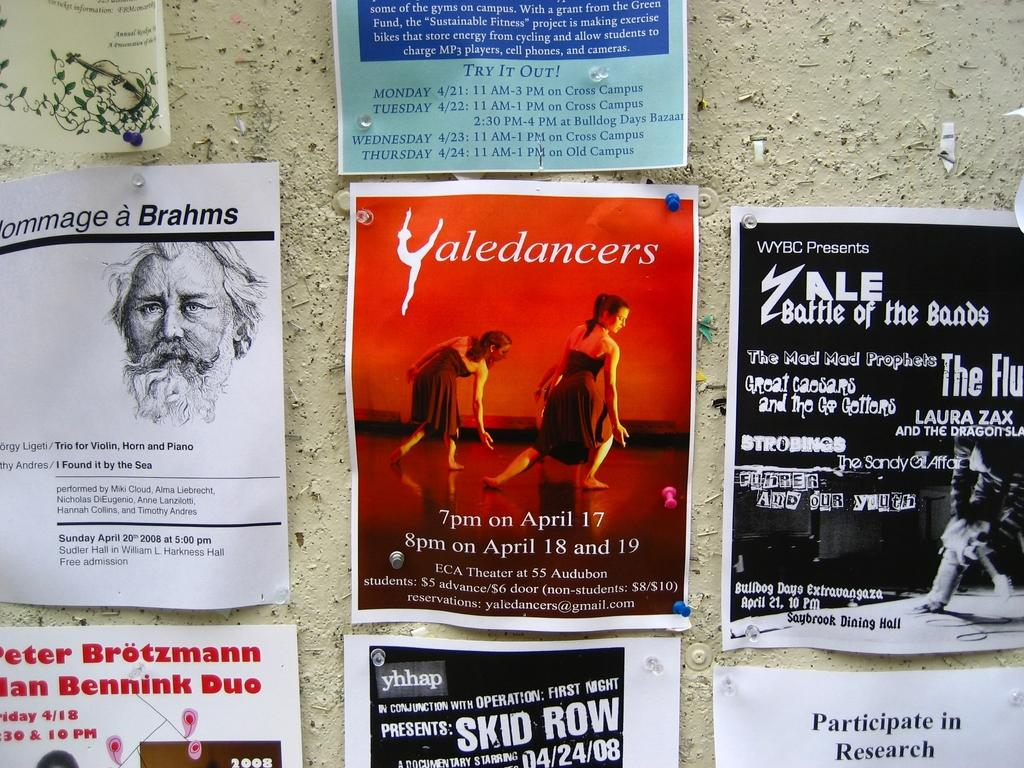<image>
Offer a succinct explanation of the picture presented. A bulletin board has many advertisements on it including one for a Yaledancers performance. 